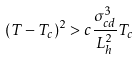<formula> <loc_0><loc_0><loc_500><loc_500>( T - T _ { c } ) ^ { 2 } > c \frac { \sigma ^ { 3 } _ { c d } } { L ^ { 2 } _ { h } } T _ { c }</formula> 